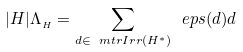<formula> <loc_0><loc_0><loc_500><loc_500>| H | \Lambda _ { _ { H } } = \sum _ { d \in \ m t r { I r r } ( H ^ { * } ) } \ e p s ( d ) d</formula> 